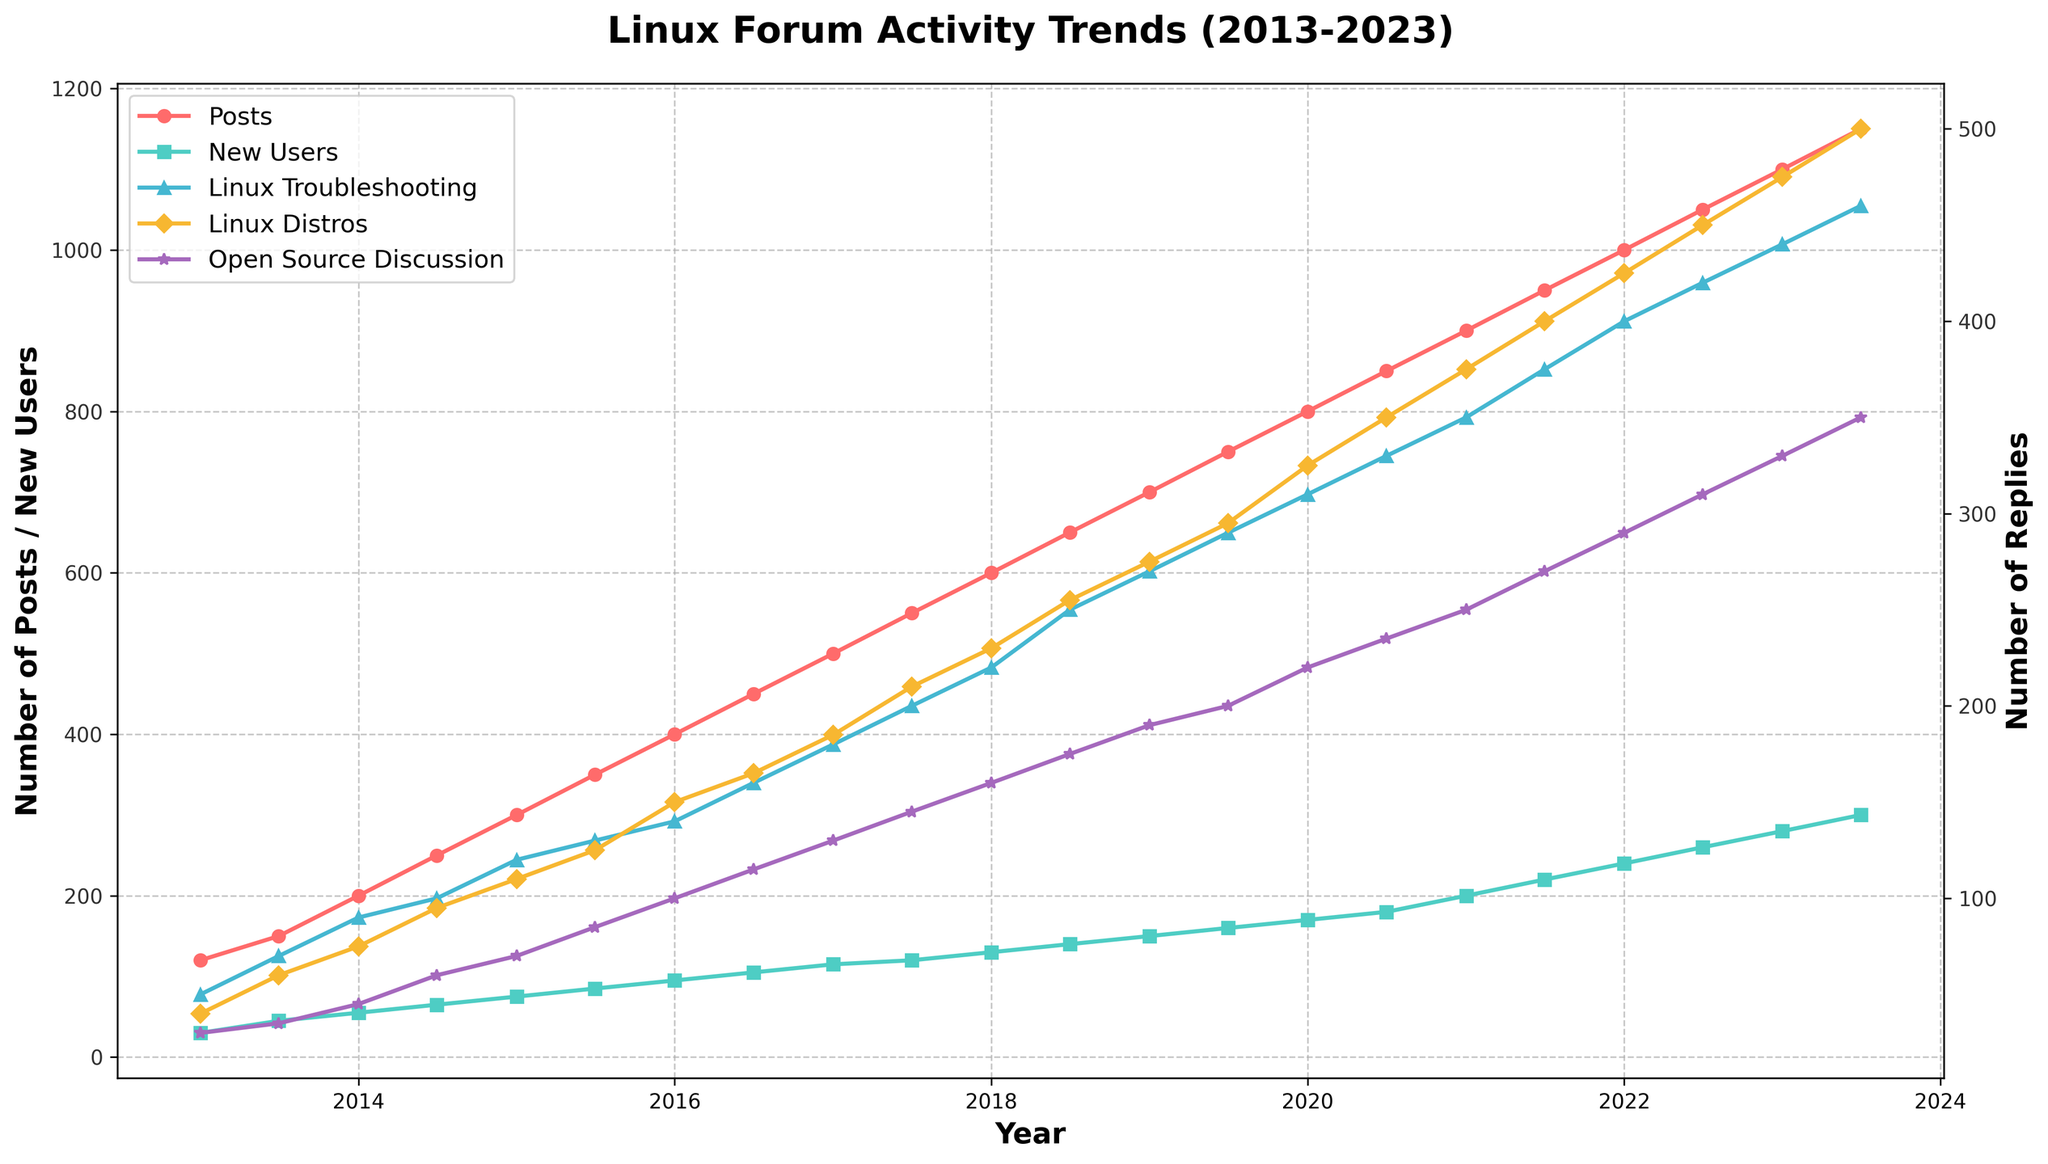What is the title of the figure? The title of the figure is typically found at the top, it summarizes the content of the plot.
Answer: Linux Forum Activity Trends (2013-2023) How many data points are present for the number of posts and new users? Each data point corresponds to an entry in the dataset, plotted over time. Looking at the x-axis, there are labels from 2013 to 2023, with two data points per year (24 total).
Answer: 24 Which category has more replies in 2023: Linux Troubleshooting or Linux Distros? To determine this, look at the lines for Linux Troubleshooting and Linux Distros on the right y-axis and check their values at the end of 2023.
Answer: Linux Distros What is the general trend of new users over the decade? Examine the line for new users, focusing on its slope and direction to determine the overall pattern from 2013 to 2023.
Answer: Increasing In which year did posts first reach 800? Track the Posts line and identify the year and month where it first crosses the 800 mark on the left y-axis.
Answer: 2020 What is the difference in the number of replies between Linux Troubleshooting and Open Source Discussion at the start of 2020? Locate the values for the two categories at the beginning of 2020 and calculate the difference: 310 (Linux Troubleshooting) - 220 (Open Source Discussion).
Answer: 90 Which reply category had the most rapid increase from 2013 to 2023? Compare the slopes of the lines for each reply category, noting the steepest incline from start to end.
Answer: Linux Distros What year experienced the largest increase in new users? Assess the new users line and identify the sharpest vertical jump, indicating the year with the greatest growth.
Answer: Between 2020 and 2021 How did the number of posts change between the beginning and the end of 2018? Observe the Posts line at the beginning and end of 2018, noting the values and the direction of change.
Answer: Increased from 600 to 650 What is the value of new users in mid-2021? Reference the line for new users and find the value corresponding to mid-2021, July.
Answer: 220 